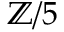Convert formula to latex. <formula><loc_0><loc_0><loc_500><loc_500>\mathbb { Z } / 5</formula> 